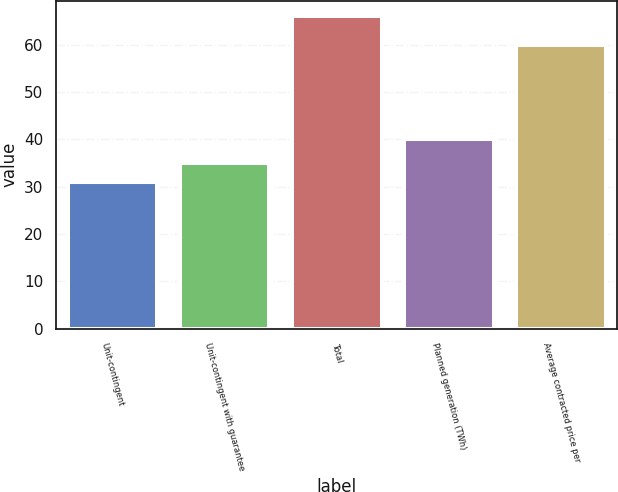Convert chart. <chart><loc_0><loc_0><loc_500><loc_500><bar_chart><fcel>Unit-contingent<fcel>Unit-contingent with guarantee<fcel>Total<fcel>Planned generation (TWh)<fcel>Average contracted price per<nl><fcel>31<fcel>35<fcel>66<fcel>40<fcel>60<nl></chart> 